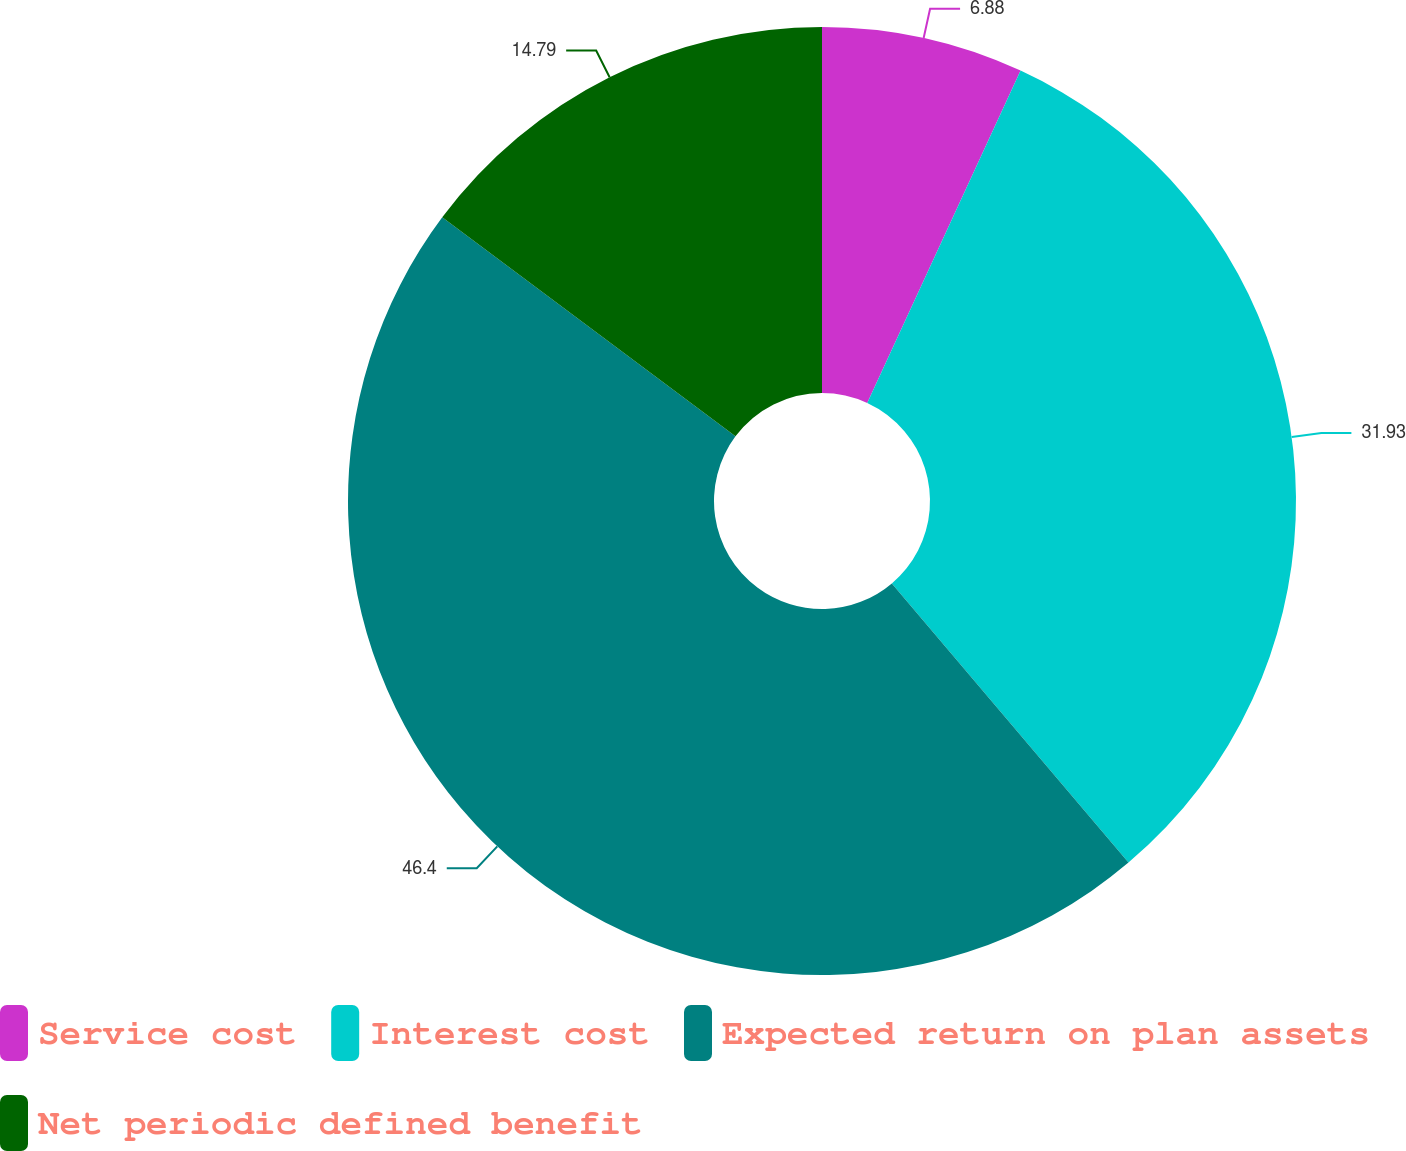Convert chart. <chart><loc_0><loc_0><loc_500><loc_500><pie_chart><fcel>Service cost<fcel>Interest cost<fcel>Expected return on plan assets<fcel>Net periodic defined benefit<nl><fcel>6.88%<fcel>31.93%<fcel>46.4%<fcel>14.79%<nl></chart> 